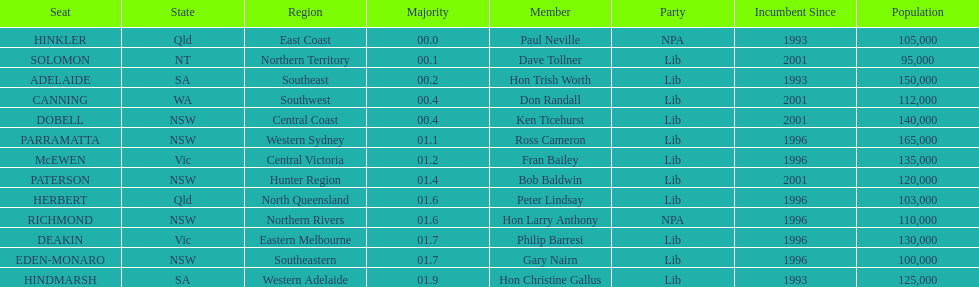What member comes next after hon trish worth? Don Randall. Would you mind parsing the complete table? {'header': ['Seat', 'State', 'Region', 'Majority', 'Member', 'Party', 'Incumbent Since', 'Population'], 'rows': [['HINKLER', 'Qld', 'East Coast', '00.0', 'Paul Neville', 'NPA', '1993', '105,000'], ['SOLOMON', 'NT', 'Northern Territory', '00.1', 'Dave Tollner', 'Lib', '2001', '95,000'], ['ADELAIDE', 'SA', 'Southeast', '00.2', 'Hon Trish Worth', 'Lib', '1993', '150,000'], ['CANNING', 'WA', 'Southwest', '00.4', 'Don Randall', 'Lib', '2001', '112,000'], ['DOBELL', 'NSW', 'Central Coast', '00.4', 'Ken Ticehurst', 'Lib', '2001', '140,000'], ['PARRAMATTA', 'NSW', 'Western Sydney', '01.1', 'Ross Cameron', 'Lib', '1996', '165,000'], ['McEWEN', 'Vic', 'Central Victoria', '01.2', 'Fran Bailey', 'Lib', '1996', '135,000'], ['PATERSON', 'NSW', 'Hunter Region', '01.4', 'Bob Baldwin', 'Lib', '2001', '120,000'], ['HERBERT', 'Qld', 'North Queensland', '01.6', 'Peter Lindsay', 'Lib', '1996', '103,000'], ['RICHMOND', 'NSW', 'Northern Rivers', '01.6', 'Hon Larry Anthony', 'NPA', '1996', '110,000'], ['DEAKIN', 'Vic', 'Eastern Melbourne', '01.7', 'Philip Barresi', 'Lib', '1996', '130,000'], ['EDEN-MONARO', 'NSW', 'Southeastern', '01.7', 'Gary Nairn', 'Lib', '1996', '100,000'], ['HINDMARSH', 'SA', 'Western Adelaide', '01.9', 'Hon Christine Gallus', 'Lib', '1993', '125,000']]} 